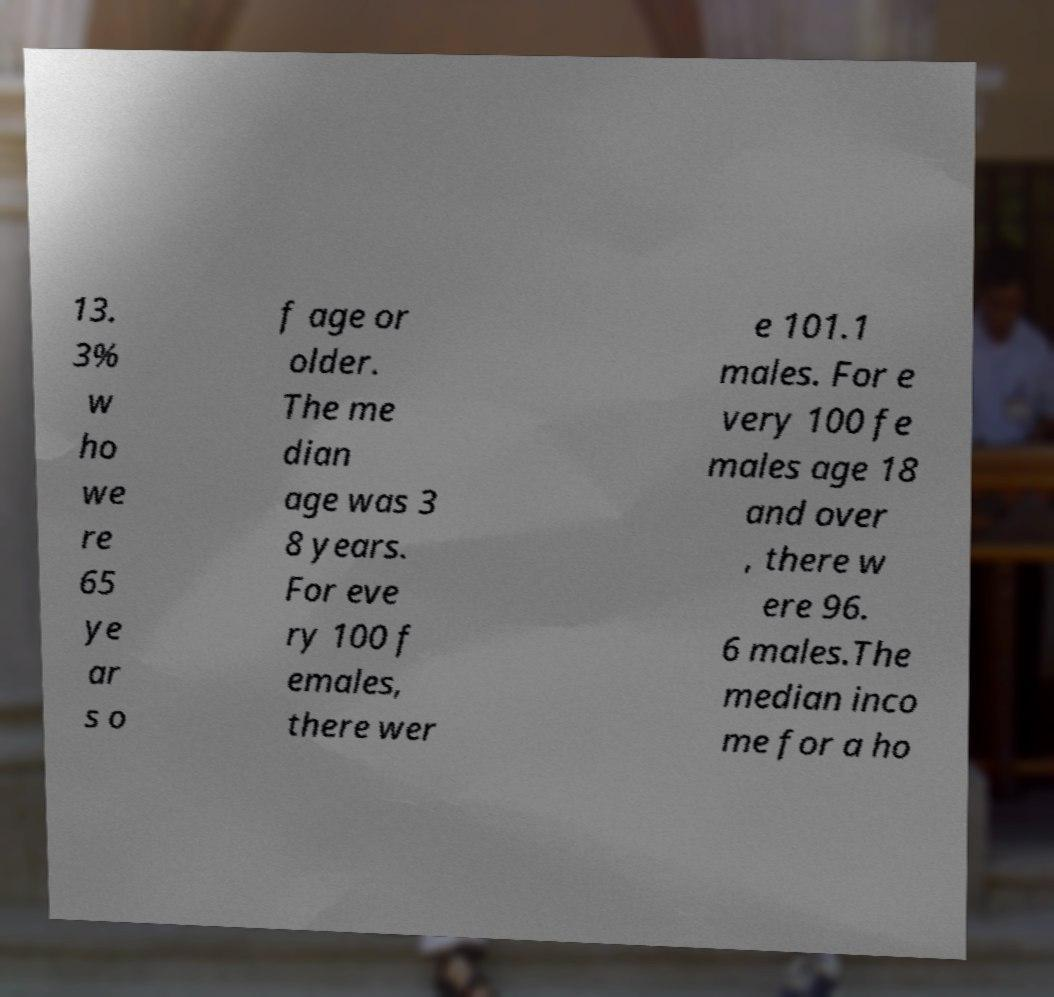For documentation purposes, I need the text within this image transcribed. Could you provide that? 13. 3% w ho we re 65 ye ar s o f age or older. The me dian age was 3 8 years. For eve ry 100 f emales, there wer e 101.1 males. For e very 100 fe males age 18 and over , there w ere 96. 6 males.The median inco me for a ho 